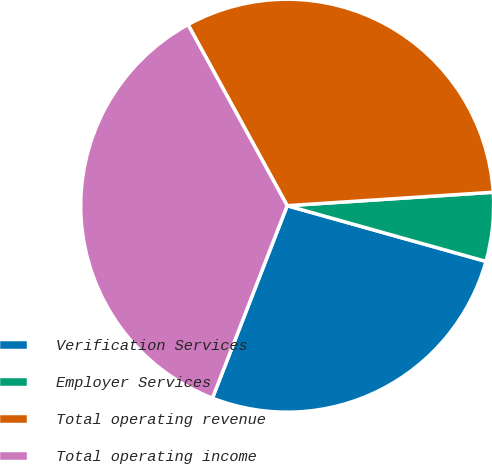Convert chart. <chart><loc_0><loc_0><loc_500><loc_500><pie_chart><fcel>Verification Services<fcel>Employer Services<fcel>Total operating revenue<fcel>Total operating income<nl><fcel>26.55%<fcel>5.39%<fcel>31.94%<fcel>36.13%<nl></chart> 